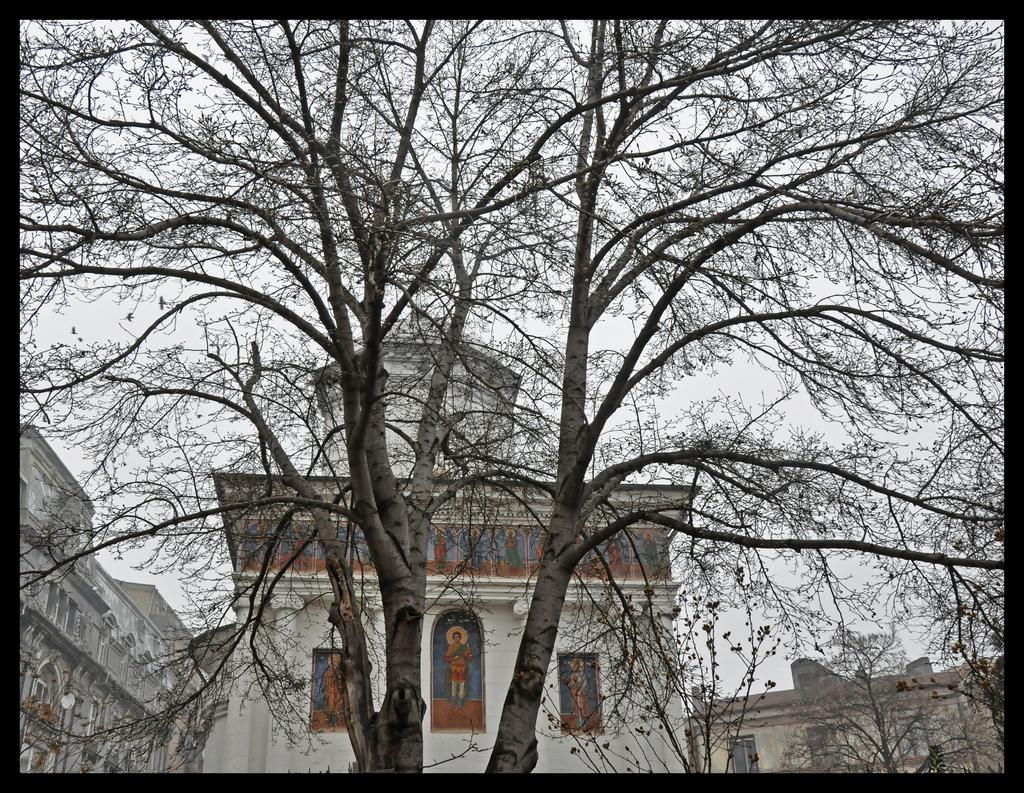What type of plant can be seen in the image? There is a tree in the image. What structures are visible behind the tree? There are buildings behind the tree in the image. What part of the natural environment is visible in the image? The sky is visible in the image. How many chickens are perched on the tree in the image? There are no chickens present in the image; it features a tree and buildings. What type of laborer is working on the tree in the image? There is no laborer present in the image; it only shows a tree and buildings. 